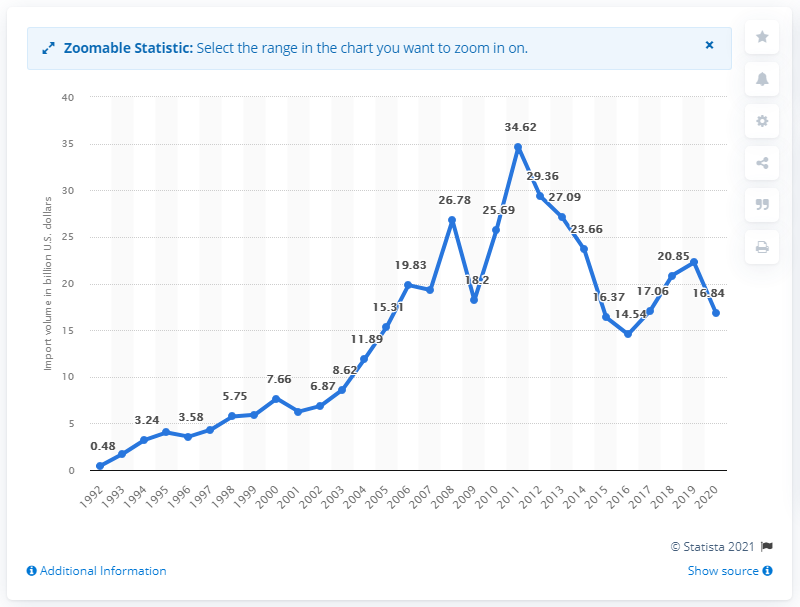Indicate a few pertinent items in this graphic. In 2019, the value of U.S. imports from Russia was 16.84 billion dollars. 